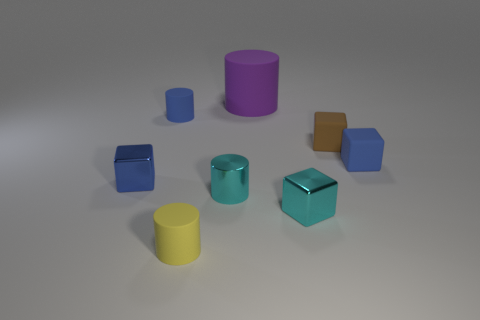What number of things are either tiny blocks that are to the left of the small cyan cube or tiny objects on the left side of the large purple object?
Offer a terse response. 4. There is a block that is both in front of the brown thing and to the right of the tiny cyan metal cube; how big is it?
Your answer should be very brief. Small. Does the purple matte object have the same shape as the thing left of the blue cylinder?
Ensure brevity in your answer.  No. How many objects are small rubber things that are in front of the brown matte thing or blue metal cubes?
Offer a very short reply. 3. Do the blue cylinder and the cyan object that is right of the large cylinder have the same material?
Ensure brevity in your answer.  No. What shape is the blue rubber object that is right of the shiny cylinder that is on the left side of the small brown cube?
Give a very brief answer. Cube. There is a large matte object; is it the same color as the small rubber block that is in front of the small brown rubber thing?
Offer a terse response. No. Is there any other thing that has the same material as the cyan cube?
Your answer should be very brief. Yes. What is the shape of the brown rubber thing?
Your answer should be compact. Cube. There is a blue cube behind the metallic thing that is to the left of the small blue cylinder; how big is it?
Provide a short and direct response. Small. 